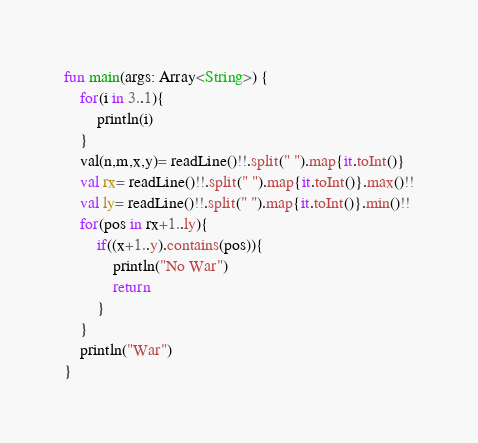<code> <loc_0><loc_0><loc_500><loc_500><_Kotlin_>fun main(args: Array<String>) {
    for(i in 3..1){
        println(i)
    }
    val(n,m,x,y)= readLine()!!.split(" ").map{it.toInt()}
    val rx= readLine()!!.split(" ").map{it.toInt()}.max()!!
    val ly= readLine()!!.split(" ").map{it.toInt()}.min()!!
    for(pos in rx+1..ly){
        if((x+1..y).contains(pos)){
            println("No War")
            return
        }
    }
    println("War")
}</code> 